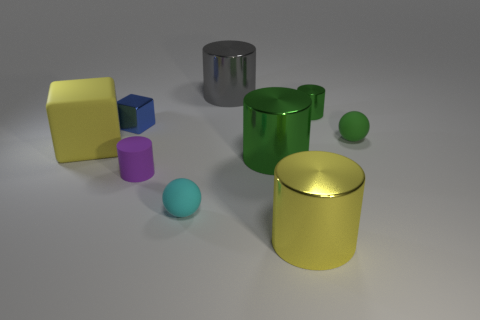Subtract all red blocks. How many green cylinders are left? 2 Subtract all green cylinders. How many cylinders are left? 3 Subtract all gray shiny cylinders. How many cylinders are left? 4 Subtract 3 cylinders. How many cylinders are left? 2 Subtract all yellow cylinders. Subtract all purple cubes. How many cylinders are left? 4 Add 1 matte objects. How many objects exist? 10 Subtract all spheres. How many objects are left? 7 Add 5 big yellow things. How many big yellow things are left? 7 Add 5 green rubber spheres. How many green rubber spheres exist? 6 Subtract 1 blue cubes. How many objects are left? 8 